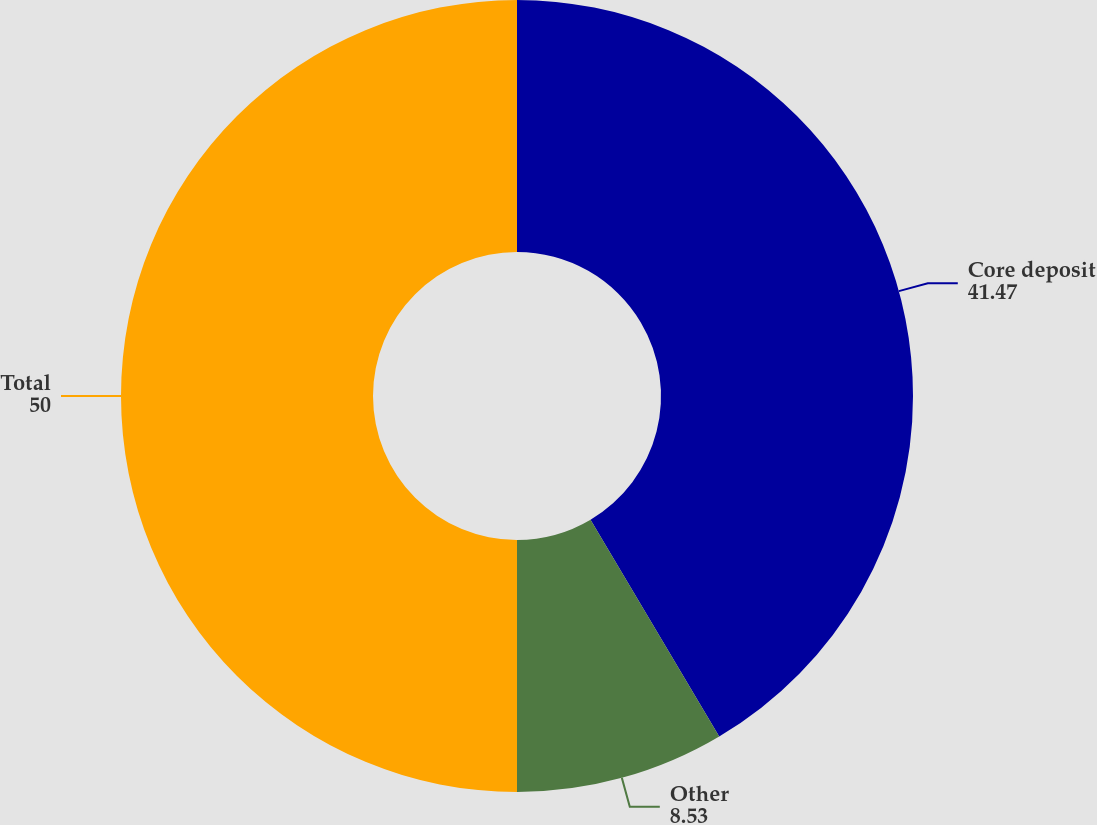<chart> <loc_0><loc_0><loc_500><loc_500><pie_chart><fcel>Core deposit<fcel>Other<fcel>Total<nl><fcel>41.47%<fcel>8.53%<fcel>50.0%<nl></chart> 